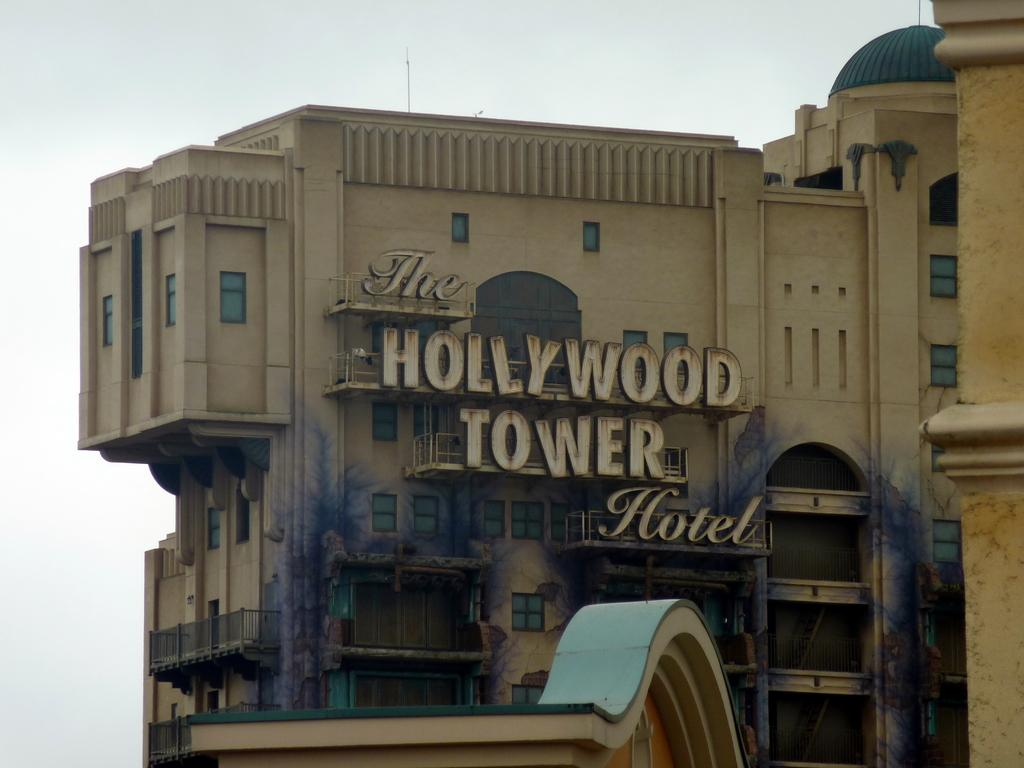<image>
Write a terse but informative summary of the picture. A photograph of The Hollywood Tower Hotel ride at an amusement park. 